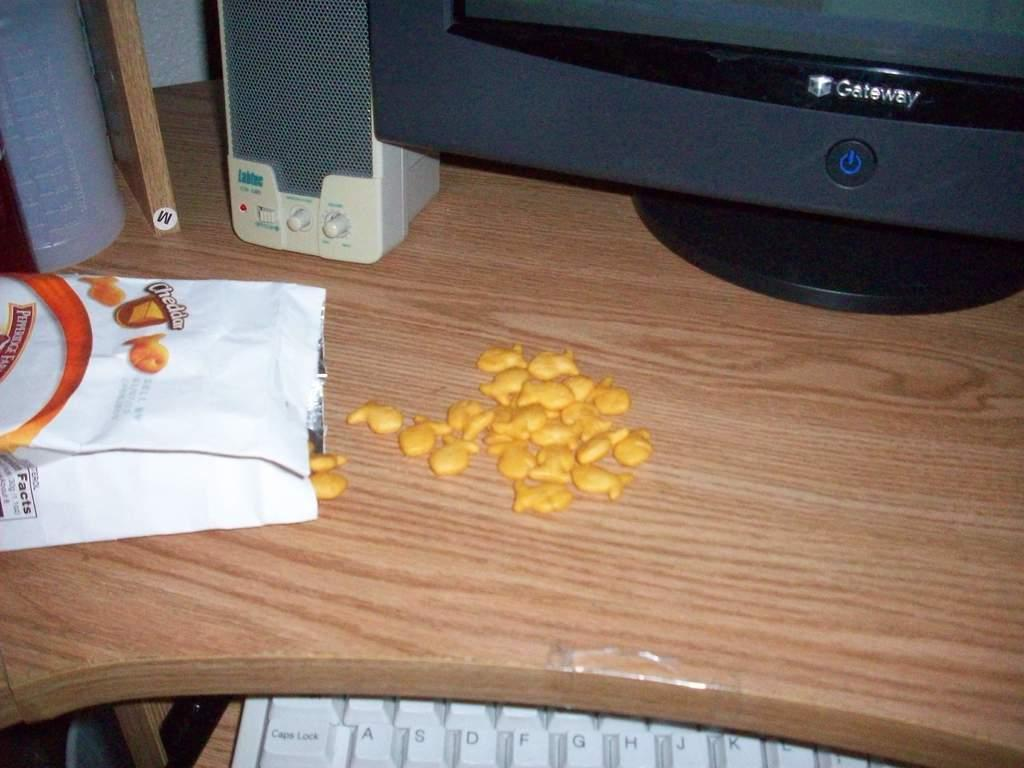What is the food item on the desk in the image? The provided facts do not specify the type of food item on the desk. What type of electronic device is visible in the image? There is a monitor in the image. What other electronic device is present in the image? There is a speaker in the image. What might be used for typing or inputting commands in the image? There is a keyboard in the image. What type of vest is hanging in the image? There is no vest present in the image. In which direction is the speaker facing in the image? The provided facts do not specify the direction the speaker is facing. 